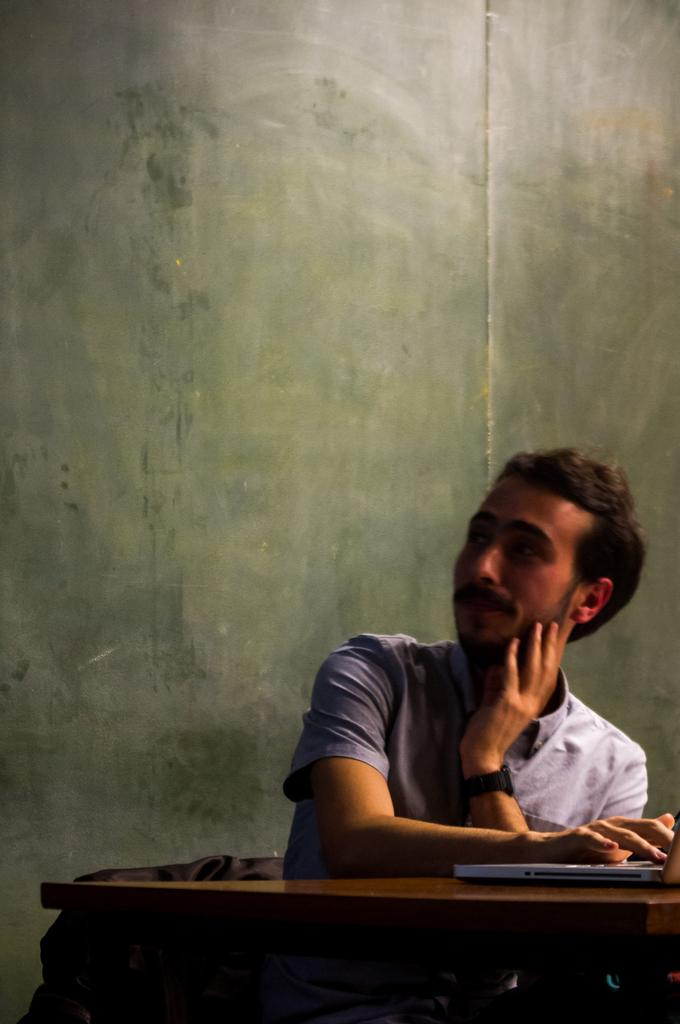Who or what is present in the image? There is a person in the image. What is the person doing in the image? The person is sitting on a chair. What other objects can be seen in the image? There is a table and a laptop on the table in the image. What type of rose is on the stove in the image? There is no rose or stove present in the image. 